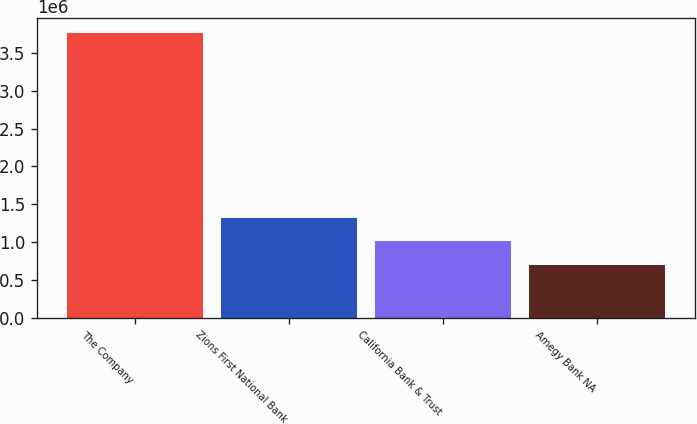Convert chart. <chart><loc_0><loc_0><loc_500><loc_500><bar_chart><fcel>The Company<fcel>Zions First National Bank<fcel>California Bank & Trust<fcel>Amegy Bank NA<nl><fcel>3.7636e+06<fcel>1.31662e+06<fcel>1.01074e+06<fcel>704869<nl></chart> 